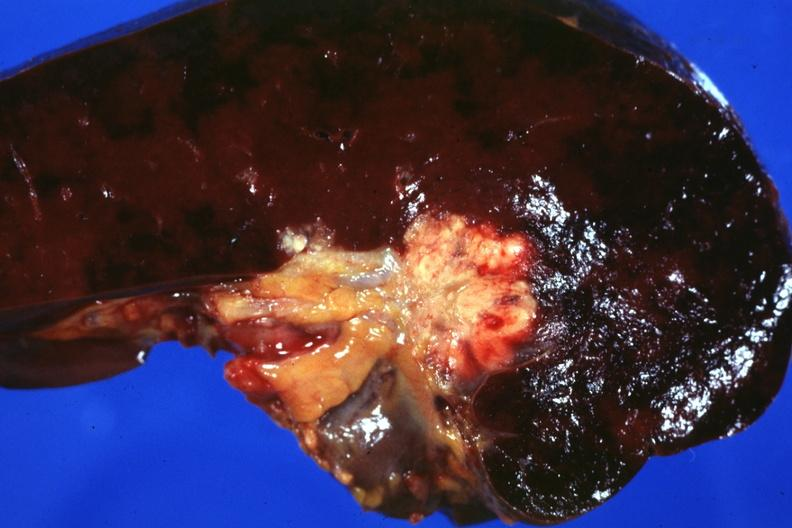what is node metastases spread?
Answer the question using a single word or phrase. Into the spleen in this case 